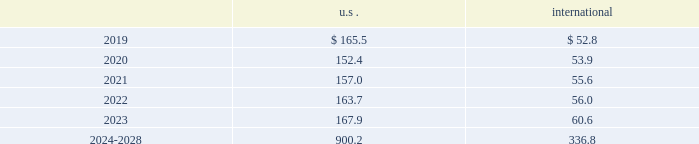The descriptions and fair value methodologies for the u.s .
And international pension plan assets are as follows : cash and cash equivalents the carrying amounts of cash and cash equivalents approximate fair value due to the short-term maturity .
Equity securities equity securities are valued at the closing market price reported on a u.s .
Or international exchange where the security is actively traded and are therefore classified as level 1 assets .
Equity mutual and pooled funds shares of mutual funds are valued at the net asset value ( nav ) of the fund and are classified as level 1 assets .
Units of pooled funds are valued at the per unit nav determined by the fund manager based on the value of the underlying traded holdings and are classified as level 2 assets .
Corporate and government bonds corporate and government bonds are classified as level 2 assets , as they are either valued at quoted market prices from observable pricing sources at the reporting date or valued based upon comparable securities with similar yields and credit ratings .
Other pooled funds other pooled funds classified as level 2 assets are valued at the nav of the shares held at year end , which is based on the fair value of the underlying investments .
Securities and interests classified as level 3 are carried at the estimated fair value .
The estimated fair value is based on the fair value of the underlying investment values , which includes estimated bids from brokers or other third-party vendor sources that utilize expected cash flow streams and other uncorroborated data including counterparty credit quality , default risk , discount rates , and the overall capital market liquidity .
Insurance contracts insurance contracts are classified as level 3 assets , as they are carried at contract value , which approximates the estimated fair value .
The estimated fair value is based on the fair value of the underlying investment of the insurance company and discount rates that require inputs with limited observability .
Contributions and projected benefit payments pension contributions to funded plans and benefit payments for unfunded plans for fiscal year 2018 were $ 68.3 .
Contributions for funded plans resulted primarily from contractual and regulatory requirements .
Benefit payments to unfunded plans were due primarily to the timing of retirements .
We anticipate contributing $ 45 to $ 65 to the defined benefit pension plans in fiscal year 2019 .
These contributions are anticipated to be driven primarily by contractual and regulatory requirements for funded plans and benefit payments for unfunded plans , which are dependent upon timing of retirements .
Projected benefit payments , which reflect expected future service , are as follows: .
These estimated benefit payments are based on assumptions about future events .
Actual benefit payments may vary significantly from these estimates. .
Considering the years 2020-2021 , what is the difference between the growth of the projected benefit payments in the u.s . and international? 
Rationale: it is the variation between the percentual increase of each estimated benefit payment .
Computations: (((55.6 / 53.9) - 1) - ((157.0 / 152.4) - 1))
Answer: 0.00136. 